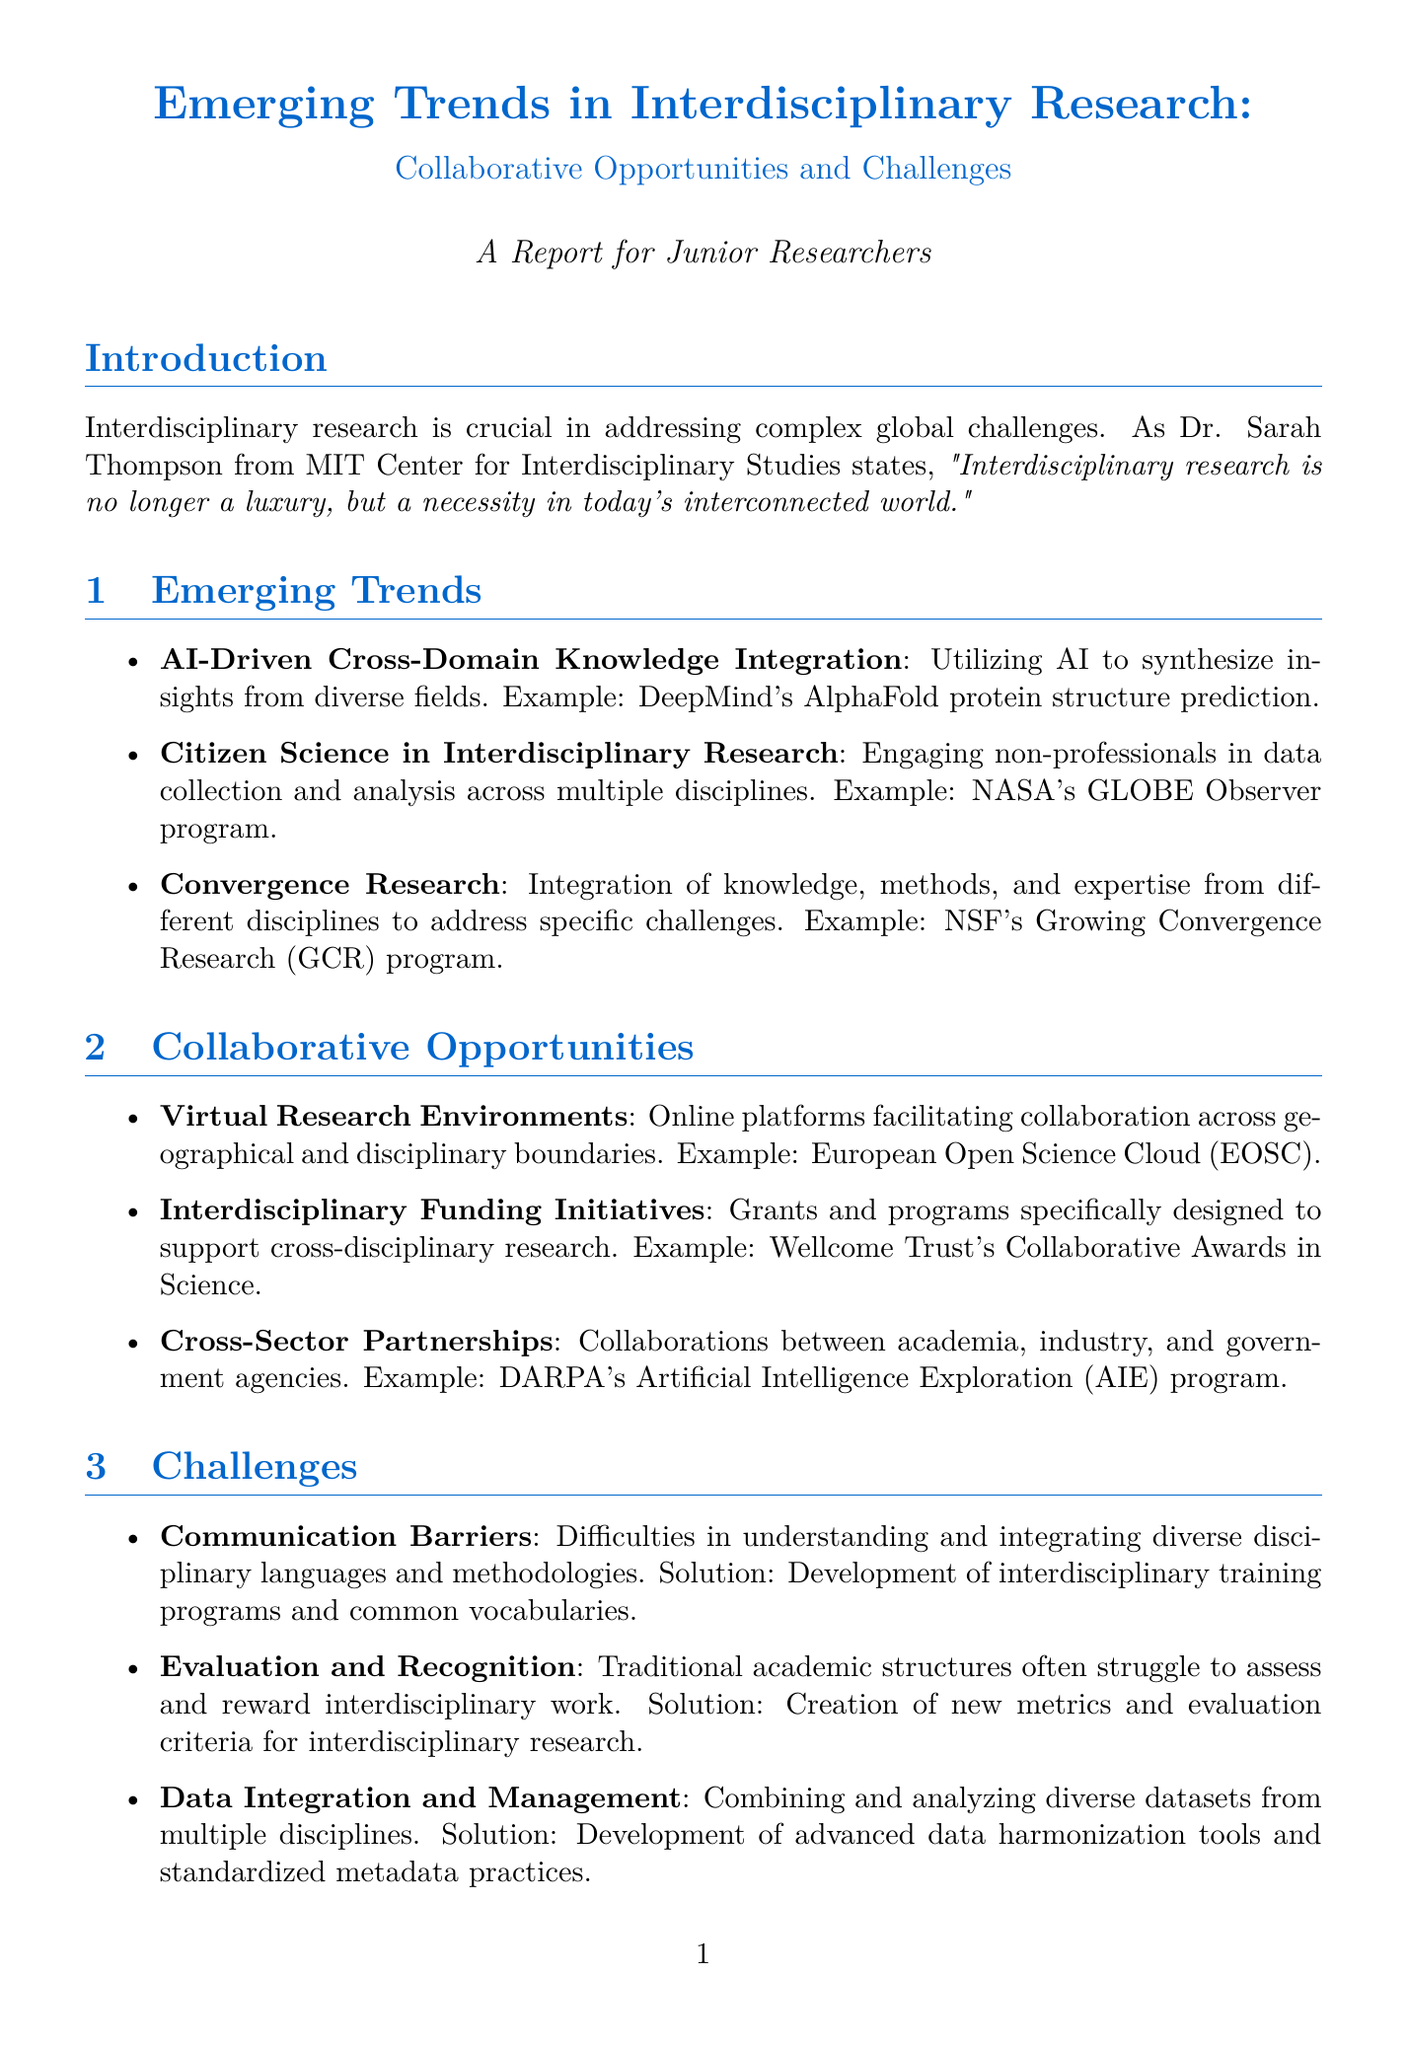What is the title of the report? The title is specified at the beginning of the document, summarizing the main topic of the report.
Answer: Emerging Trends in Interdisciplinary Research: Collaborative Opportunities and Challenges Who is the expert quoted in the introduction? The document lists Dr. Sarah Thompson from MIT Center for Interdisciplinary Studies as the expert providing a quote.
Answer: Dr. Sarah Thompson What is one example project related to AI-Driven Cross-Domain Knowledge Integration? The project provided as an example for this trend is mentioned in the section on emerging trends.
Answer: DeepMind's AlphaFold protein structure prediction What is a key prediction mentioned in the future outlook? The future outlook section includes a list of predictions; one of these is highlighted directly.
Answer: Increased emphasis on transdisciplinary approaches What is the first collaborative opportunity listed in the report? The report lists collaborative opportunities and the first one is specified prominently.
Answer: Virtual Research Environments What challenge involves difficulties in understanding disciplinary languages? The document specifies communication barriers as a challenge that encompasses this issue.
Answer: Communication Barriers What is one potential solution for the challenge related to evaluation and recognition? The report outlines potential solutions for challenges, and one is specifically related to evaluation and recognition.
Answer: Creation of new metrics and evaluation criteria for interdisciplinary research Which center is mentioned in Appendix A? Appendix A includes notable interdisciplinary research centers, and one of them is specifically listed.
Answer: Santa Fe Institute, USA 